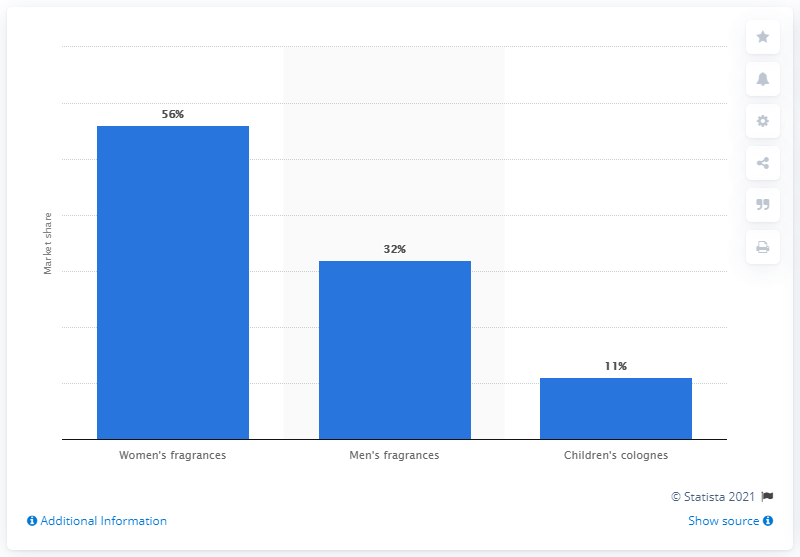Point out several critical features in this image. In 2017, women's fragrances accounted for approximately 56% of the Brazilian mass fragrances market. 